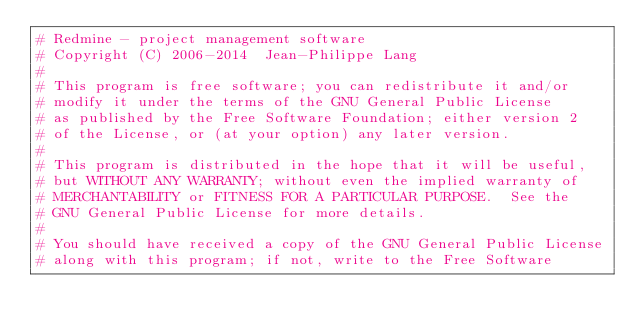Convert code to text. <code><loc_0><loc_0><loc_500><loc_500><_Ruby_># Redmine - project management software
# Copyright (C) 2006-2014  Jean-Philippe Lang
#
# This program is free software; you can redistribute it and/or
# modify it under the terms of the GNU General Public License
# as published by the Free Software Foundation; either version 2
# of the License, or (at your option) any later version.
#
# This program is distributed in the hope that it will be useful,
# but WITHOUT ANY WARRANTY; without even the implied warranty of
# MERCHANTABILITY or FITNESS FOR A PARTICULAR PURPOSE.  See the
# GNU General Public License for more details.
#
# You should have received a copy of the GNU General Public License
# along with this program; if not, write to the Free Software</code> 